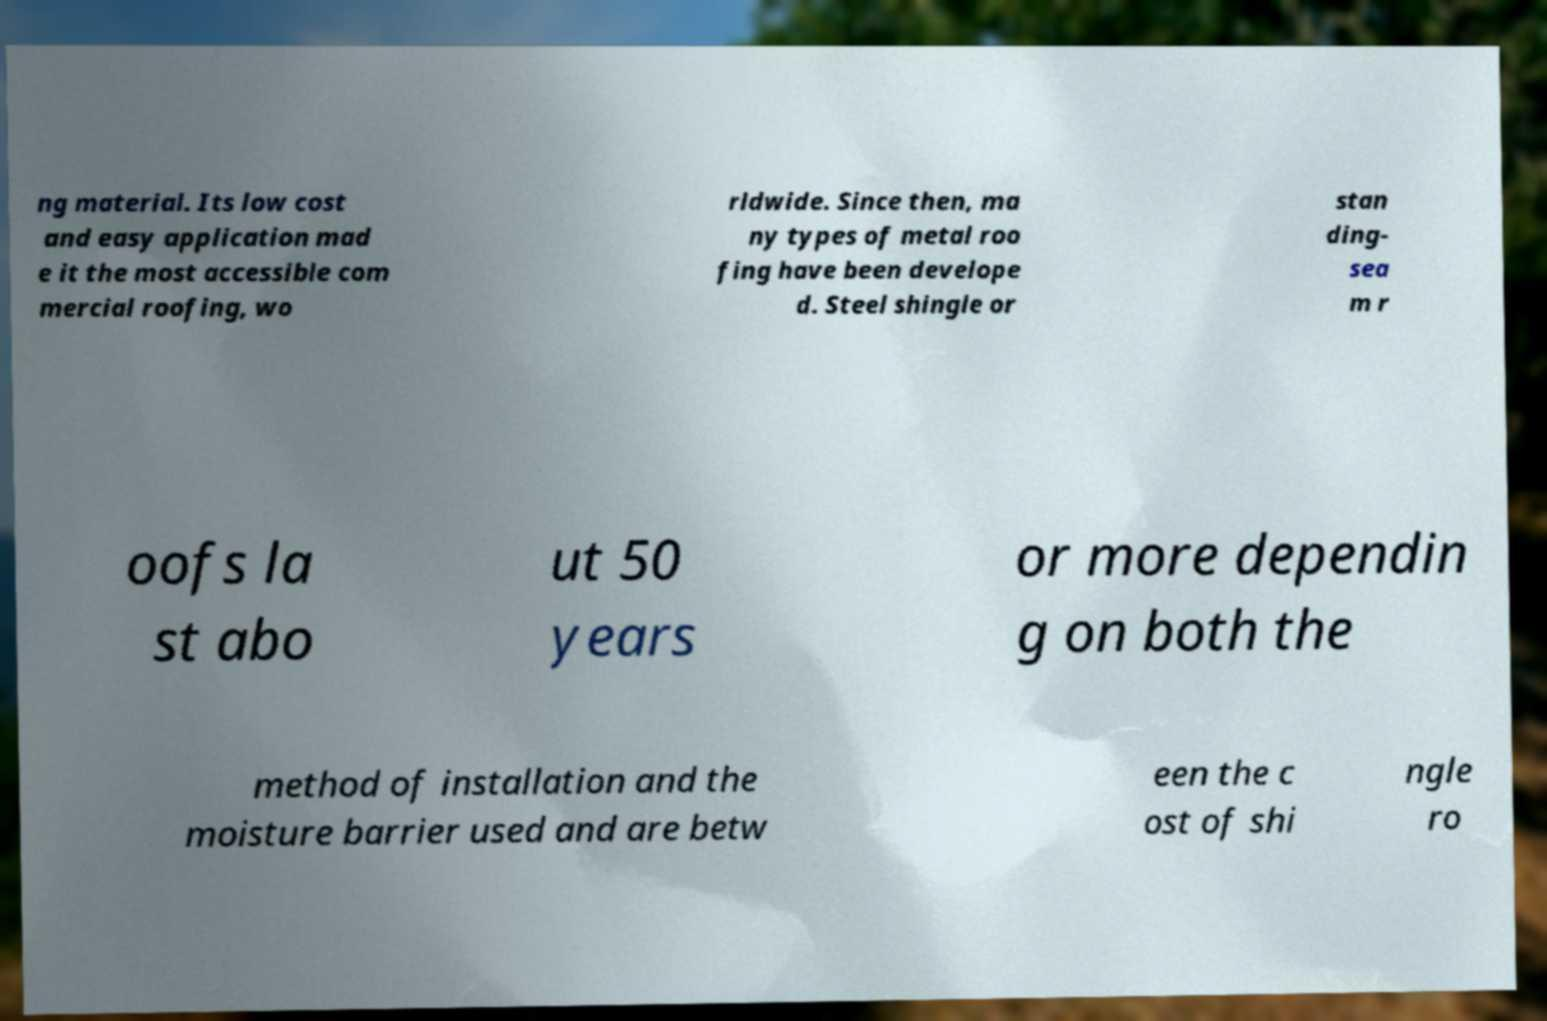Can you read and provide the text displayed in the image?This photo seems to have some interesting text. Can you extract and type it out for me? ng material. Its low cost and easy application mad e it the most accessible com mercial roofing, wo rldwide. Since then, ma ny types of metal roo fing have been develope d. Steel shingle or stan ding- sea m r oofs la st abo ut 50 years or more dependin g on both the method of installation and the moisture barrier used and are betw een the c ost of shi ngle ro 